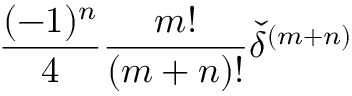Convert formula to latex. <formula><loc_0><loc_0><loc_500><loc_500>\frac { ( - 1 ) ^ { n } } { 4 } \frac { m ! } { ( m + n ) ! } { \check { \delta } } ^ { ( m + n ) }</formula> 